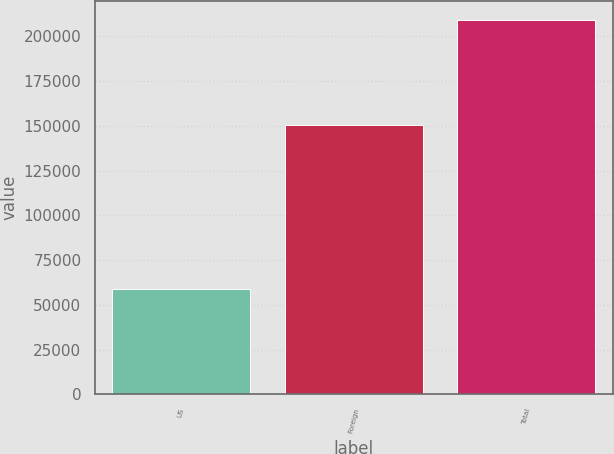Convert chart to OTSL. <chart><loc_0><loc_0><loc_500><loc_500><bar_chart><fcel>US<fcel>Foreign<fcel>Total<nl><fcel>58964<fcel>150251<fcel>209215<nl></chart> 